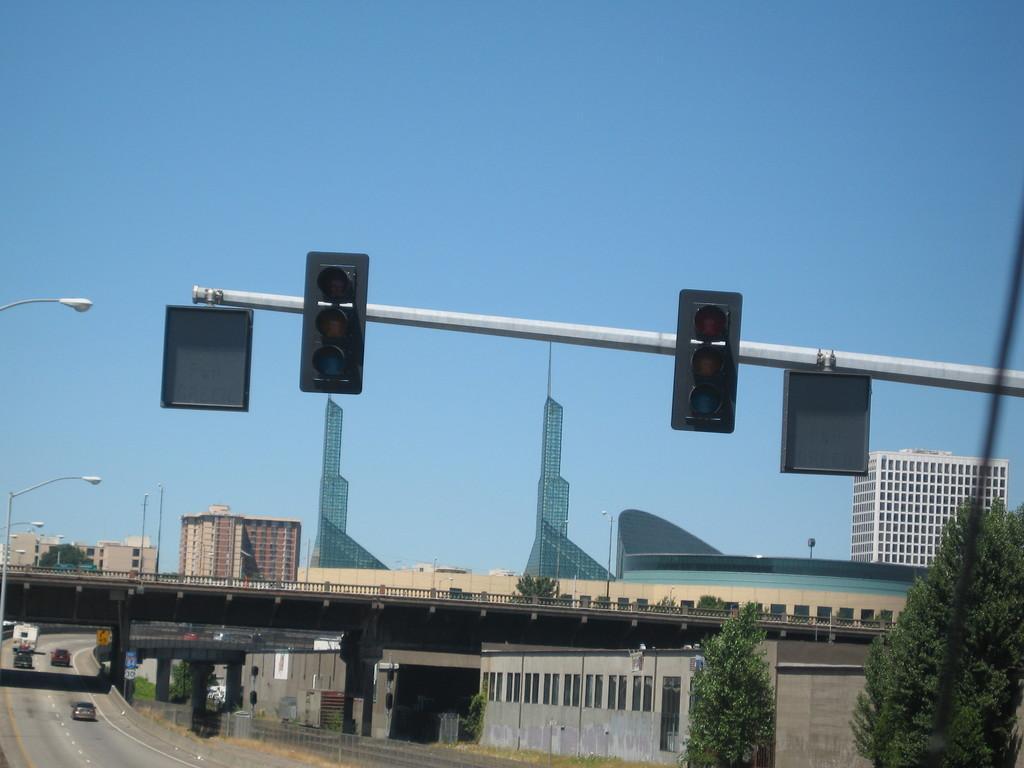Please provide a concise description of this image. In the center of the image we can see group of traffic signals on a pole. In the foreground we can see a bridge, a group of cars parked on the road. To the left side of the image we can see some light poles. In the background, we can see a group of buildings with windows, trees and the sky. 